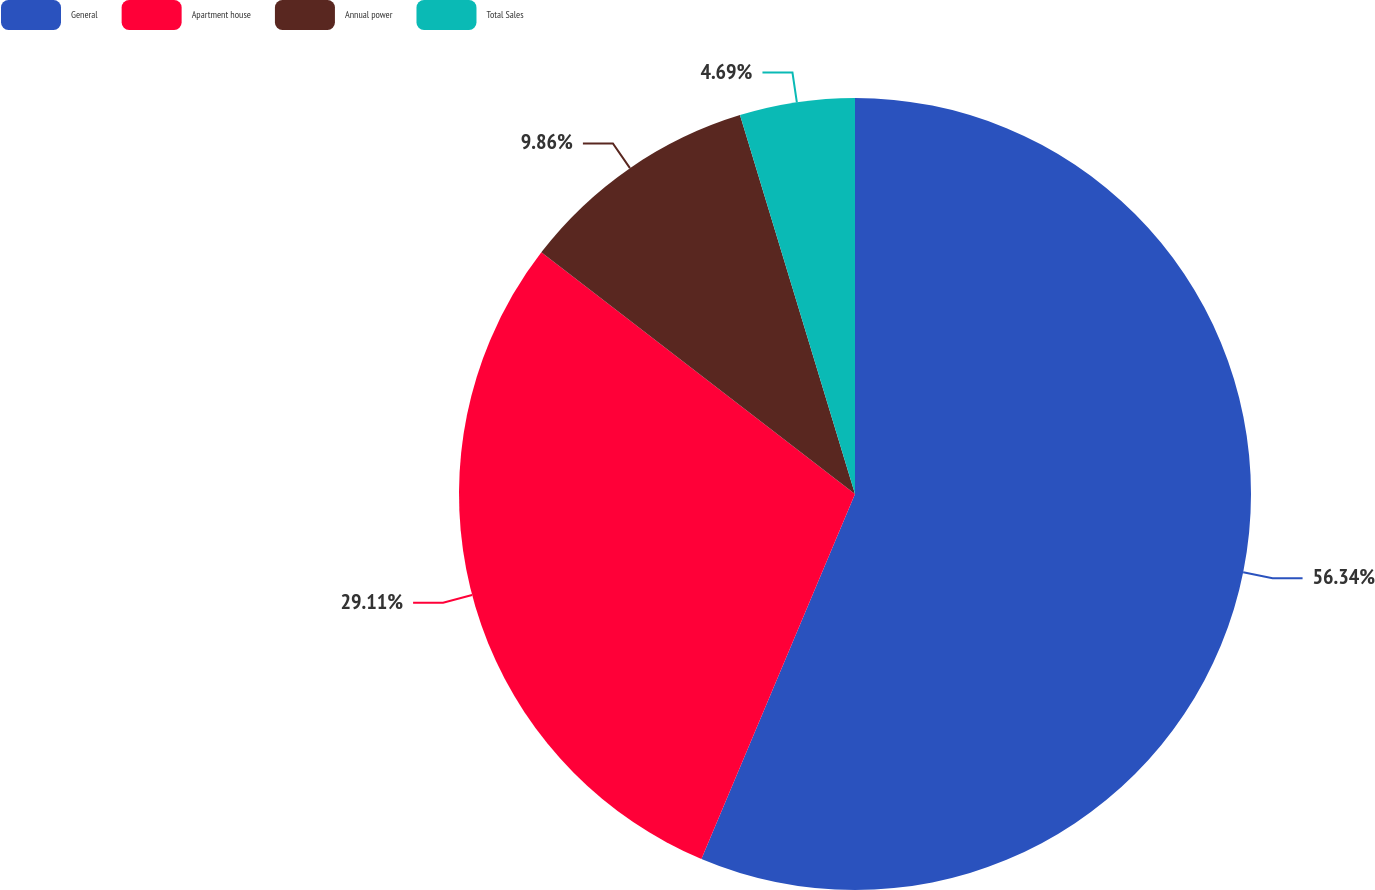Convert chart to OTSL. <chart><loc_0><loc_0><loc_500><loc_500><pie_chart><fcel>General<fcel>Apartment house<fcel>Annual power<fcel>Total Sales<nl><fcel>56.34%<fcel>29.11%<fcel>9.86%<fcel>4.69%<nl></chart> 